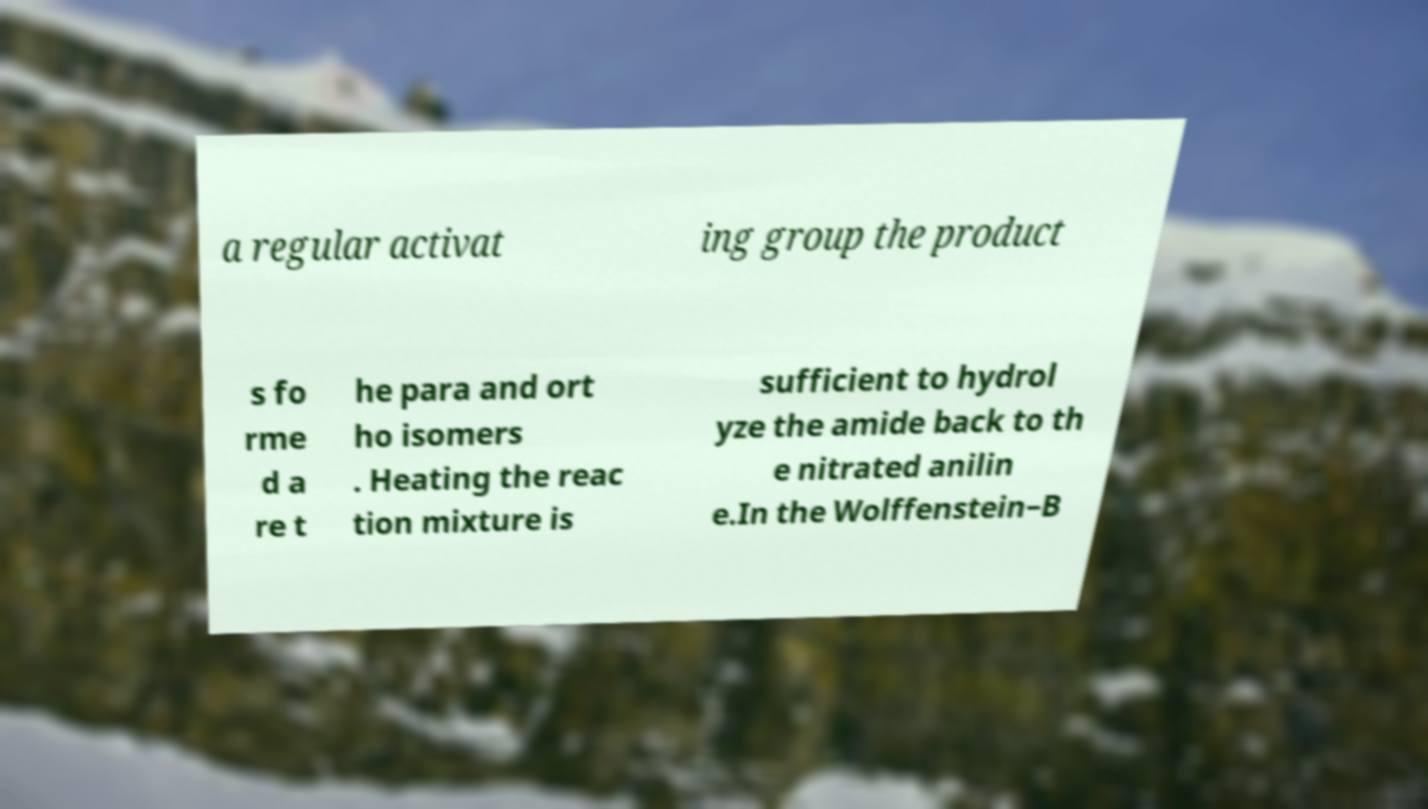For documentation purposes, I need the text within this image transcribed. Could you provide that? a regular activat ing group the product s fo rme d a re t he para and ort ho isomers . Heating the reac tion mixture is sufficient to hydrol yze the amide back to th e nitrated anilin e.In the Wolffenstein–B 